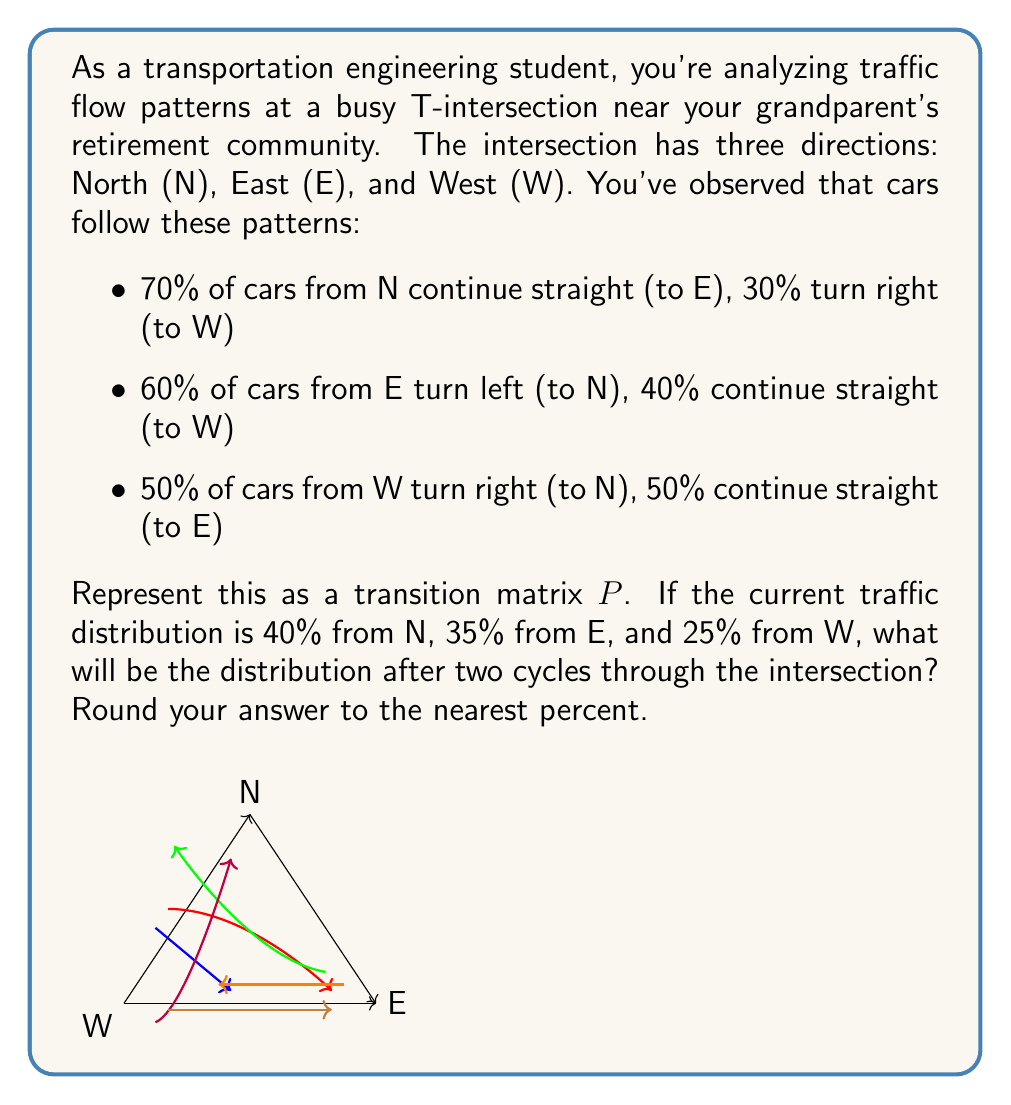Could you help me with this problem? Let's approach this step-by-step:

1) First, we need to create the transition matrix $P$. The rows represent the starting direction, and the columns represent the ending direction, in the order N, E, W.

   $$P = \begin{bmatrix}
   0 & 0.7 & 0.3 \\
   0.6 & 0 & 0.4 \\
   0.5 & 0.5 & 0
   \end{bmatrix}$$

2) The initial distribution vector is:
   
   $$v_0 = \begin{bmatrix} 0.4 \\ 0.35 \\ 0.25 \end{bmatrix}$$

3) To find the distribution after two cycles, we need to multiply $P$ by itself and then by $v_0$:

   $$v_2 = P^2 v_0$$

4) Let's calculate $P^2$ first:

   $$P^2 = \begin{bmatrix}
   0 & 0.7 & 0.3 \\
   0.6 & 0 & 0.4 \\
   0.5 & 0.5 & 0
   \end{bmatrix} \times 
   \begin{bmatrix}
   0 & 0.7 & 0.3 \\
   0.6 & 0 & 0.4 \\
   0.5 & 0.5 & 0
   \end{bmatrix}$$

   $$P^2 = \begin{bmatrix}
   0.57 & 0.35 & 0.08 \\
   0.30 & 0.62 & 0.08 \\
   0.30 & 0.35 & 0.35
   \end{bmatrix}$$

5) Now, we multiply $P^2$ by $v_0$:

   $$v_2 = \begin{bmatrix}
   0.57 & 0.35 & 0.08 \\
   0.30 & 0.62 & 0.08 \\
   0.30 & 0.35 & 0.35
   \end{bmatrix} \times 
   \begin{bmatrix} 0.4 \\ 0.35 \\ 0.25 \end{bmatrix}$$

6) Performing the matrix multiplication:

   $$v_2 = \begin{bmatrix}
   0.4185 \\
   0.3890 \\
   0.1925
   \end{bmatrix}$$

7) Rounding to the nearest percent:

   $$v_2 \approx \begin{bmatrix} 42\% \\ 39\% \\ 19\% \end{bmatrix}$$

Therefore, after two cycles, approximately 42% of traffic will be from N, 39% from E, and 19% from W.
Answer: (42%, 39%, 19%) 